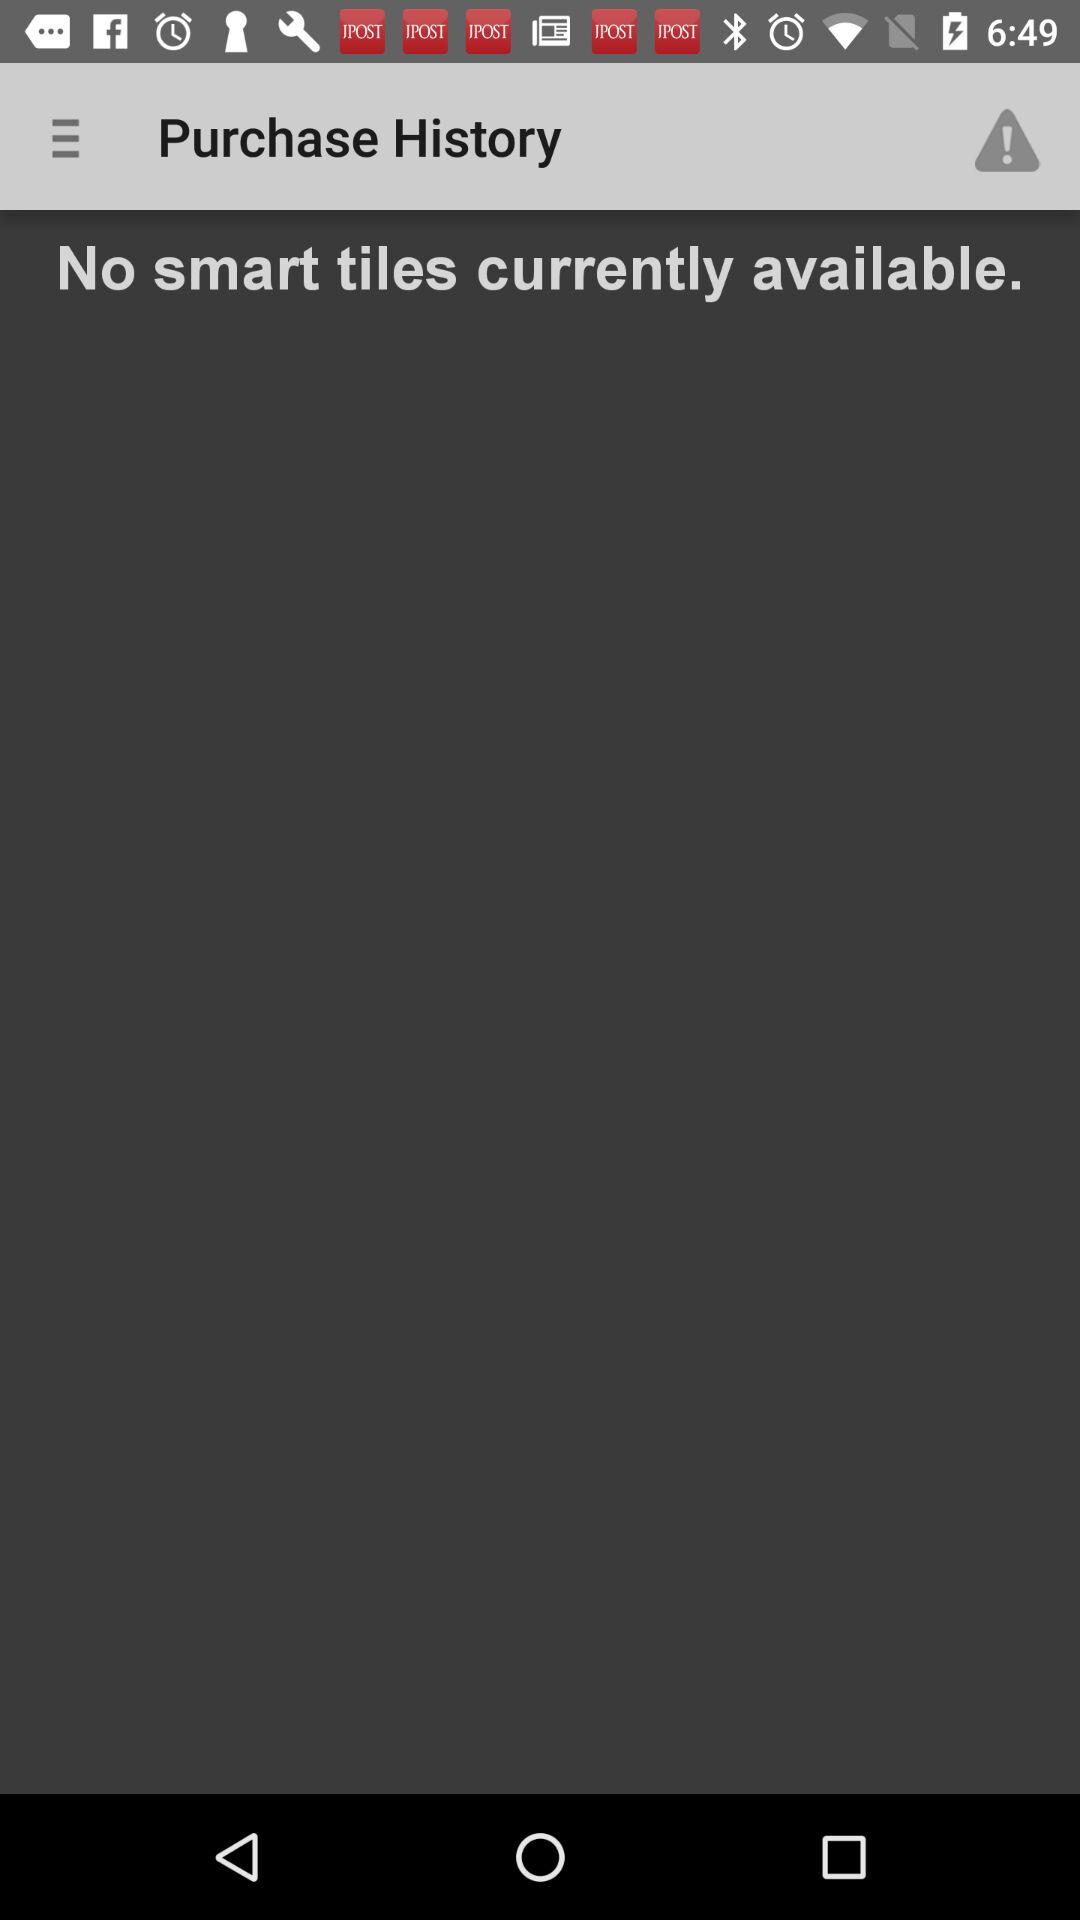Are there any smart tiles currently available? There are currently no smart tiles available. 